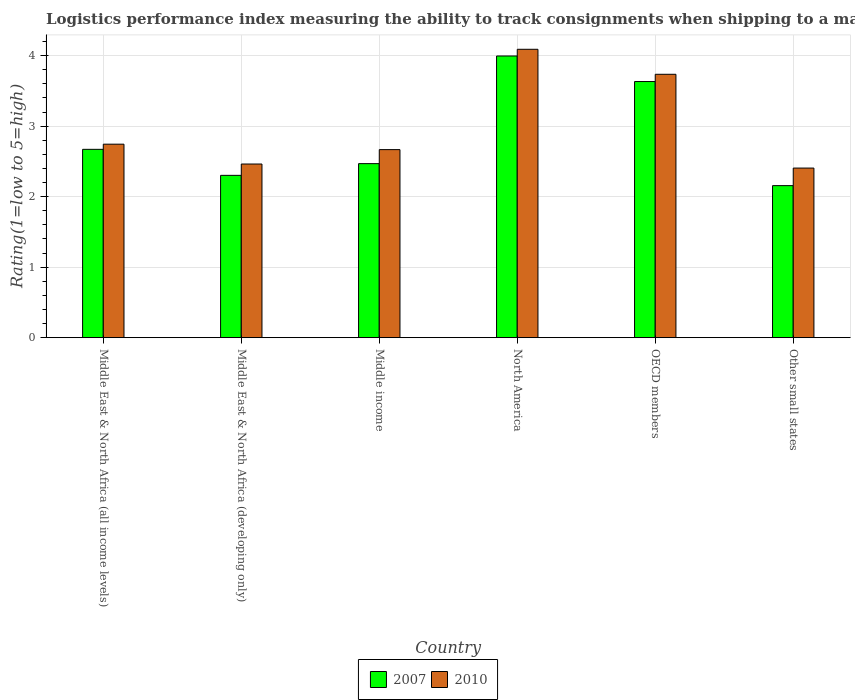How many different coloured bars are there?
Ensure brevity in your answer.  2. Are the number of bars per tick equal to the number of legend labels?
Ensure brevity in your answer.  Yes. Are the number of bars on each tick of the X-axis equal?
Provide a succinct answer. Yes. How many bars are there on the 1st tick from the left?
Keep it short and to the point. 2. How many bars are there on the 5th tick from the right?
Your response must be concise. 2. What is the label of the 3rd group of bars from the left?
Offer a terse response. Middle income. What is the Logistic performance index in 2007 in Middle East & North Africa (developing only)?
Ensure brevity in your answer.  2.3. Across all countries, what is the maximum Logistic performance index in 2010?
Offer a terse response. 4.09. Across all countries, what is the minimum Logistic performance index in 2010?
Your answer should be compact. 2.41. In which country was the Logistic performance index in 2007 minimum?
Ensure brevity in your answer.  Other small states. What is the total Logistic performance index in 2010 in the graph?
Your answer should be compact. 18.11. What is the difference between the Logistic performance index in 2007 in Middle East & North Africa (all income levels) and that in OECD members?
Make the answer very short. -0.96. What is the difference between the Logistic performance index in 2010 in North America and the Logistic performance index in 2007 in OECD members?
Provide a succinct answer. 0.46. What is the average Logistic performance index in 2007 per country?
Provide a succinct answer. 2.87. What is the difference between the Logistic performance index of/in 2007 and Logistic performance index of/in 2010 in OECD members?
Your response must be concise. -0.1. What is the ratio of the Logistic performance index in 2010 in Middle East & North Africa (all income levels) to that in North America?
Keep it short and to the point. 0.67. Is the Logistic performance index in 2010 in Middle East & North Africa (developing only) less than that in Other small states?
Make the answer very short. No. What is the difference between the highest and the second highest Logistic performance index in 2010?
Give a very brief answer. -0.99. What is the difference between the highest and the lowest Logistic performance index in 2007?
Your answer should be compact. 1.84. In how many countries, is the Logistic performance index in 2010 greater than the average Logistic performance index in 2010 taken over all countries?
Keep it short and to the point. 2. What does the 1st bar from the left in Middle income represents?
Offer a very short reply. 2007. Are all the bars in the graph horizontal?
Your answer should be very brief. No. How many countries are there in the graph?
Provide a short and direct response. 6. What is the difference between two consecutive major ticks on the Y-axis?
Provide a succinct answer. 1. Does the graph contain any zero values?
Make the answer very short. No. How many legend labels are there?
Give a very brief answer. 2. What is the title of the graph?
Keep it short and to the point. Logistics performance index measuring the ability to track consignments when shipping to a market. What is the label or title of the X-axis?
Provide a succinct answer. Country. What is the label or title of the Y-axis?
Your response must be concise. Rating(1=low to 5=high). What is the Rating(1=low to 5=high) of 2007 in Middle East & North Africa (all income levels)?
Your answer should be compact. 2.67. What is the Rating(1=low to 5=high) in 2010 in Middle East & North Africa (all income levels)?
Provide a short and direct response. 2.74. What is the Rating(1=low to 5=high) of 2007 in Middle East & North Africa (developing only)?
Ensure brevity in your answer.  2.3. What is the Rating(1=low to 5=high) in 2010 in Middle East & North Africa (developing only)?
Ensure brevity in your answer.  2.46. What is the Rating(1=low to 5=high) in 2007 in Middle income?
Offer a very short reply. 2.47. What is the Rating(1=low to 5=high) of 2010 in Middle income?
Your answer should be compact. 2.67. What is the Rating(1=low to 5=high) in 2007 in North America?
Offer a very short reply. 4. What is the Rating(1=low to 5=high) in 2010 in North America?
Give a very brief answer. 4.09. What is the Rating(1=low to 5=high) in 2007 in OECD members?
Ensure brevity in your answer.  3.63. What is the Rating(1=low to 5=high) in 2010 in OECD members?
Make the answer very short. 3.74. What is the Rating(1=low to 5=high) in 2007 in Other small states?
Provide a succinct answer. 2.16. What is the Rating(1=low to 5=high) in 2010 in Other small states?
Offer a terse response. 2.41. Across all countries, what is the maximum Rating(1=low to 5=high) of 2007?
Your response must be concise. 4. Across all countries, what is the maximum Rating(1=low to 5=high) in 2010?
Give a very brief answer. 4.09. Across all countries, what is the minimum Rating(1=low to 5=high) in 2007?
Ensure brevity in your answer.  2.16. Across all countries, what is the minimum Rating(1=low to 5=high) of 2010?
Your answer should be compact. 2.41. What is the total Rating(1=low to 5=high) of 2007 in the graph?
Your answer should be compact. 17.23. What is the total Rating(1=low to 5=high) of 2010 in the graph?
Ensure brevity in your answer.  18.11. What is the difference between the Rating(1=low to 5=high) in 2007 in Middle East & North Africa (all income levels) and that in Middle East & North Africa (developing only)?
Keep it short and to the point. 0.37. What is the difference between the Rating(1=low to 5=high) of 2010 in Middle East & North Africa (all income levels) and that in Middle East & North Africa (developing only)?
Your answer should be very brief. 0.28. What is the difference between the Rating(1=low to 5=high) in 2007 in Middle East & North Africa (all income levels) and that in Middle income?
Your answer should be compact. 0.2. What is the difference between the Rating(1=low to 5=high) in 2010 in Middle East & North Africa (all income levels) and that in Middle income?
Make the answer very short. 0.08. What is the difference between the Rating(1=low to 5=high) of 2007 in Middle East & North Africa (all income levels) and that in North America?
Provide a short and direct response. -1.32. What is the difference between the Rating(1=low to 5=high) of 2010 in Middle East & North Africa (all income levels) and that in North America?
Offer a very short reply. -1.35. What is the difference between the Rating(1=low to 5=high) in 2007 in Middle East & North Africa (all income levels) and that in OECD members?
Your answer should be very brief. -0.96. What is the difference between the Rating(1=low to 5=high) in 2010 in Middle East & North Africa (all income levels) and that in OECD members?
Offer a very short reply. -0.99. What is the difference between the Rating(1=low to 5=high) of 2007 in Middle East & North Africa (all income levels) and that in Other small states?
Keep it short and to the point. 0.51. What is the difference between the Rating(1=low to 5=high) of 2010 in Middle East & North Africa (all income levels) and that in Other small states?
Give a very brief answer. 0.34. What is the difference between the Rating(1=low to 5=high) of 2007 in Middle East & North Africa (developing only) and that in Middle income?
Keep it short and to the point. -0.17. What is the difference between the Rating(1=low to 5=high) in 2010 in Middle East & North Africa (developing only) and that in Middle income?
Give a very brief answer. -0.2. What is the difference between the Rating(1=low to 5=high) in 2007 in Middle East & North Africa (developing only) and that in North America?
Ensure brevity in your answer.  -1.69. What is the difference between the Rating(1=low to 5=high) in 2010 in Middle East & North Africa (developing only) and that in North America?
Keep it short and to the point. -1.63. What is the difference between the Rating(1=low to 5=high) of 2007 in Middle East & North Africa (developing only) and that in OECD members?
Give a very brief answer. -1.33. What is the difference between the Rating(1=low to 5=high) of 2010 in Middle East & North Africa (developing only) and that in OECD members?
Keep it short and to the point. -1.27. What is the difference between the Rating(1=low to 5=high) in 2007 in Middle East & North Africa (developing only) and that in Other small states?
Your answer should be compact. 0.15. What is the difference between the Rating(1=low to 5=high) of 2010 in Middle East & North Africa (developing only) and that in Other small states?
Your answer should be compact. 0.06. What is the difference between the Rating(1=low to 5=high) of 2007 in Middle income and that in North America?
Offer a very short reply. -1.53. What is the difference between the Rating(1=low to 5=high) in 2010 in Middle income and that in North America?
Provide a succinct answer. -1.42. What is the difference between the Rating(1=low to 5=high) of 2007 in Middle income and that in OECD members?
Provide a short and direct response. -1.16. What is the difference between the Rating(1=low to 5=high) in 2010 in Middle income and that in OECD members?
Your response must be concise. -1.07. What is the difference between the Rating(1=low to 5=high) in 2007 in Middle income and that in Other small states?
Your response must be concise. 0.31. What is the difference between the Rating(1=low to 5=high) in 2010 in Middle income and that in Other small states?
Your answer should be compact. 0.26. What is the difference between the Rating(1=low to 5=high) of 2007 in North America and that in OECD members?
Give a very brief answer. 0.36. What is the difference between the Rating(1=low to 5=high) in 2010 in North America and that in OECD members?
Your response must be concise. 0.35. What is the difference between the Rating(1=low to 5=high) in 2007 in North America and that in Other small states?
Your answer should be compact. 1.84. What is the difference between the Rating(1=low to 5=high) of 2010 in North America and that in Other small states?
Make the answer very short. 1.68. What is the difference between the Rating(1=low to 5=high) of 2007 in OECD members and that in Other small states?
Provide a succinct answer. 1.48. What is the difference between the Rating(1=low to 5=high) in 2010 in OECD members and that in Other small states?
Your response must be concise. 1.33. What is the difference between the Rating(1=low to 5=high) in 2007 in Middle East & North Africa (all income levels) and the Rating(1=low to 5=high) in 2010 in Middle East & North Africa (developing only)?
Ensure brevity in your answer.  0.21. What is the difference between the Rating(1=low to 5=high) of 2007 in Middle East & North Africa (all income levels) and the Rating(1=low to 5=high) of 2010 in Middle income?
Provide a short and direct response. 0. What is the difference between the Rating(1=low to 5=high) of 2007 in Middle East & North Africa (all income levels) and the Rating(1=low to 5=high) of 2010 in North America?
Your response must be concise. -1.42. What is the difference between the Rating(1=low to 5=high) of 2007 in Middle East & North Africa (all income levels) and the Rating(1=low to 5=high) of 2010 in OECD members?
Offer a very short reply. -1.06. What is the difference between the Rating(1=low to 5=high) in 2007 in Middle East & North Africa (all income levels) and the Rating(1=low to 5=high) in 2010 in Other small states?
Provide a short and direct response. 0.27. What is the difference between the Rating(1=low to 5=high) of 2007 in Middle East & North Africa (developing only) and the Rating(1=low to 5=high) of 2010 in Middle income?
Keep it short and to the point. -0.37. What is the difference between the Rating(1=low to 5=high) in 2007 in Middle East & North Africa (developing only) and the Rating(1=low to 5=high) in 2010 in North America?
Your response must be concise. -1.79. What is the difference between the Rating(1=low to 5=high) of 2007 in Middle East & North Africa (developing only) and the Rating(1=low to 5=high) of 2010 in OECD members?
Offer a very short reply. -1.43. What is the difference between the Rating(1=low to 5=high) of 2007 in Middle East & North Africa (developing only) and the Rating(1=low to 5=high) of 2010 in Other small states?
Ensure brevity in your answer.  -0.1. What is the difference between the Rating(1=low to 5=high) in 2007 in Middle income and the Rating(1=low to 5=high) in 2010 in North America?
Ensure brevity in your answer.  -1.62. What is the difference between the Rating(1=low to 5=high) in 2007 in Middle income and the Rating(1=low to 5=high) in 2010 in OECD members?
Provide a succinct answer. -1.27. What is the difference between the Rating(1=low to 5=high) in 2007 in Middle income and the Rating(1=low to 5=high) in 2010 in Other small states?
Make the answer very short. 0.06. What is the difference between the Rating(1=low to 5=high) of 2007 in North America and the Rating(1=low to 5=high) of 2010 in OECD members?
Give a very brief answer. 0.26. What is the difference between the Rating(1=low to 5=high) of 2007 in North America and the Rating(1=low to 5=high) of 2010 in Other small states?
Your response must be concise. 1.59. What is the difference between the Rating(1=low to 5=high) in 2007 in OECD members and the Rating(1=low to 5=high) in 2010 in Other small states?
Provide a succinct answer. 1.23. What is the average Rating(1=low to 5=high) in 2007 per country?
Your response must be concise. 2.87. What is the average Rating(1=low to 5=high) in 2010 per country?
Your answer should be very brief. 3.02. What is the difference between the Rating(1=low to 5=high) of 2007 and Rating(1=low to 5=high) of 2010 in Middle East & North Africa (all income levels)?
Give a very brief answer. -0.07. What is the difference between the Rating(1=low to 5=high) in 2007 and Rating(1=low to 5=high) in 2010 in Middle East & North Africa (developing only)?
Provide a short and direct response. -0.16. What is the difference between the Rating(1=low to 5=high) in 2007 and Rating(1=low to 5=high) in 2010 in Middle income?
Keep it short and to the point. -0.2. What is the difference between the Rating(1=low to 5=high) in 2007 and Rating(1=low to 5=high) in 2010 in North America?
Offer a terse response. -0.1. What is the difference between the Rating(1=low to 5=high) of 2007 and Rating(1=low to 5=high) of 2010 in OECD members?
Provide a short and direct response. -0.1. What is the difference between the Rating(1=low to 5=high) of 2007 and Rating(1=low to 5=high) of 2010 in Other small states?
Give a very brief answer. -0.25. What is the ratio of the Rating(1=low to 5=high) of 2007 in Middle East & North Africa (all income levels) to that in Middle East & North Africa (developing only)?
Offer a very short reply. 1.16. What is the ratio of the Rating(1=low to 5=high) in 2010 in Middle East & North Africa (all income levels) to that in Middle East & North Africa (developing only)?
Your response must be concise. 1.11. What is the ratio of the Rating(1=low to 5=high) of 2007 in Middle East & North Africa (all income levels) to that in Middle income?
Your response must be concise. 1.08. What is the ratio of the Rating(1=low to 5=high) of 2010 in Middle East & North Africa (all income levels) to that in Middle income?
Make the answer very short. 1.03. What is the ratio of the Rating(1=low to 5=high) in 2007 in Middle East & North Africa (all income levels) to that in North America?
Your response must be concise. 0.67. What is the ratio of the Rating(1=low to 5=high) in 2010 in Middle East & North Africa (all income levels) to that in North America?
Ensure brevity in your answer.  0.67. What is the ratio of the Rating(1=low to 5=high) in 2007 in Middle East & North Africa (all income levels) to that in OECD members?
Give a very brief answer. 0.74. What is the ratio of the Rating(1=low to 5=high) in 2010 in Middle East & North Africa (all income levels) to that in OECD members?
Make the answer very short. 0.73. What is the ratio of the Rating(1=low to 5=high) in 2007 in Middle East & North Africa (all income levels) to that in Other small states?
Give a very brief answer. 1.24. What is the ratio of the Rating(1=low to 5=high) of 2010 in Middle East & North Africa (all income levels) to that in Other small states?
Your answer should be very brief. 1.14. What is the ratio of the Rating(1=low to 5=high) in 2007 in Middle East & North Africa (developing only) to that in Middle income?
Your response must be concise. 0.93. What is the ratio of the Rating(1=low to 5=high) in 2010 in Middle East & North Africa (developing only) to that in Middle income?
Provide a short and direct response. 0.92. What is the ratio of the Rating(1=low to 5=high) of 2007 in Middle East & North Africa (developing only) to that in North America?
Provide a short and direct response. 0.58. What is the ratio of the Rating(1=low to 5=high) of 2010 in Middle East & North Africa (developing only) to that in North America?
Offer a very short reply. 0.6. What is the ratio of the Rating(1=low to 5=high) in 2007 in Middle East & North Africa (developing only) to that in OECD members?
Provide a short and direct response. 0.63. What is the ratio of the Rating(1=low to 5=high) in 2010 in Middle East & North Africa (developing only) to that in OECD members?
Your answer should be compact. 0.66. What is the ratio of the Rating(1=low to 5=high) of 2007 in Middle East & North Africa (developing only) to that in Other small states?
Your answer should be compact. 1.07. What is the ratio of the Rating(1=low to 5=high) of 2010 in Middle East & North Africa (developing only) to that in Other small states?
Your answer should be very brief. 1.02. What is the ratio of the Rating(1=low to 5=high) of 2007 in Middle income to that in North America?
Your response must be concise. 0.62. What is the ratio of the Rating(1=low to 5=high) of 2010 in Middle income to that in North America?
Your answer should be very brief. 0.65. What is the ratio of the Rating(1=low to 5=high) in 2007 in Middle income to that in OECD members?
Ensure brevity in your answer.  0.68. What is the ratio of the Rating(1=low to 5=high) in 2010 in Middle income to that in OECD members?
Ensure brevity in your answer.  0.71. What is the ratio of the Rating(1=low to 5=high) in 2007 in Middle income to that in Other small states?
Your answer should be very brief. 1.14. What is the ratio of the Rating(1=low to 5=high) in 2010 in Middle income to that in Other small states?
Keep it short and to the point. 1.11. What is the ratio of the Rating(1=low to 5=high) of 2007 in North America to that in OECD members?
Provide a short and direct response. 1.1. What is the ratio of the Rating(1=low to 5=high) in 2010 in North America to that in OECD members?
Give a very brief answer. 1.09. What is the ratio of the Rating(1=low to 5=high) of 2007 in North America to that in Other small states?
Your answer should be compact. 1.85. What is the ratio of the Rating(1=low to 5=high) of 2010 in North America to that in Other small states?
Give a very brief answer. 1.7. What is the ratio of the Rating(1=low to 5=high) in 2007 in OECD members to that in Other small states?
Offer a terse response. 1.68. What is the ratio of the Rating(1=low to 5=high) of 2010 in OECD members to that in Other small states?
Ensure brevity in your answer.  1.55. What is the difference between the highest and the second highest Rating(1=low to 5=high) of 2007?
Give a very brief answer. 0.36. What is the difference between the highest and the second highest Rating(1=low to 5=high) in 2010?
Provide a succinct answer. 0.35. What is the difference between the highest and the lowest Rating(1=low to 5=high) in 2007?
Offer a terse response. 1.84. What is the difference between the highest and the lowest Rating(1=low to 5=high) of 2010?
Provide a short and direct response. 1.68. 